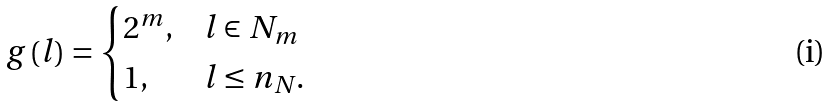<formula> <loc_0><loc_0><loc_500><loc_500>g \left ( l \right ) = \begin{cases} 2 ^ { m } , & l \in N _ { m } \\ 1 , & l \leq n _ { N } . \end{cases}</formula> 